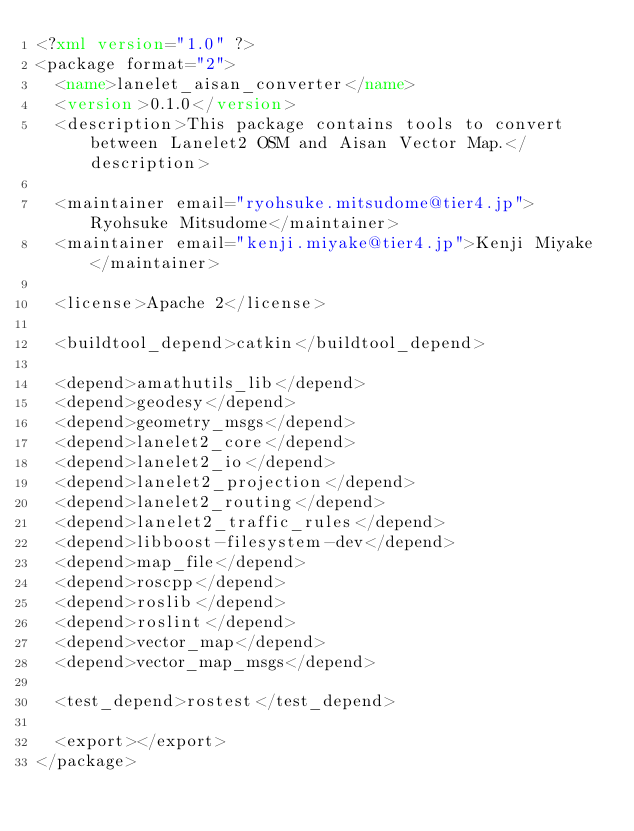Convert code to text. <code><loc_0><loc_0><loc_500><loc_500><_XML_><?xml version="1.0" ?>
<package format="2">
  <name>lanelet_aisan_converter</name>
  <version>0.1.0</version>
  <description>This package contains tools to convert between Lanelet2 OSM and Aisan Vector Map.</description>

  <maintainer email="ryohsuke.mitsudome@tier4.jp">Ryohsuke Mitsudome</maintainer>
  <maintainer email="kenji.miyake@tier4.jp">Kenji Miyake</maintainer>

  <license>Apache 2</license>

  <buildtool_depend>catkin</buildtool_depend>

  <depend>amathutils_lib</depend>
  <depend>geodesy</depend>
  <depend>geometry_msgs</depend>
  <depend>lanelet2_core</depend>
  <depend>lanelet2_io</depend>
  <depend>lanelet2_projection</depend>
  <depend>lanelet2_routing</depend>
  <depend>lanelet2_traffic_rules</depend>
  <depend>libboost-filesystem-dev</depend>
  <depend>map_file</depend>
  <depend>roscpp</depend>
  <depend>roslib</depend>
  <depend>roslint</depend>
  <depend>vector_map</depend>
  <depend>vector_map_msgs</depend>

  <test_depend>rostest</test_depend>

  <export></export>
</package>
</code> 